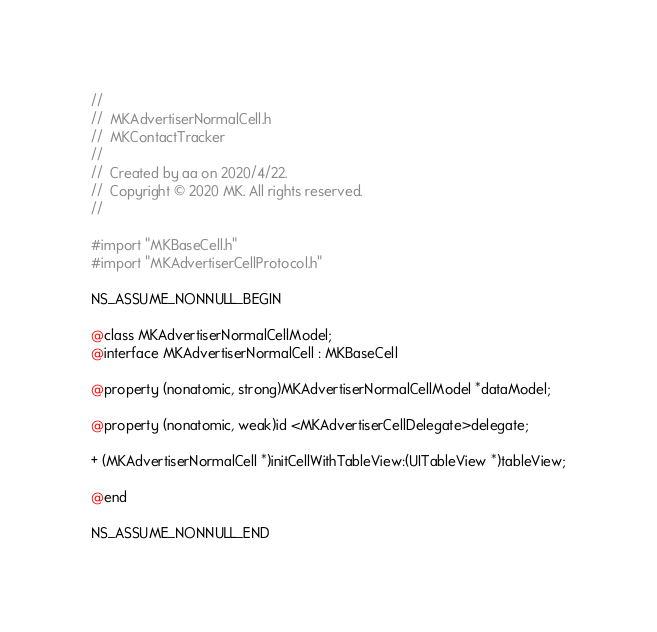Convert code to text. <code><loc_0><loc_0><loc_500><loc_500><_C_>//
//  MKAdvertiserNormalCell.h
//  MKContactTracker
//
//  Created by aa on 2020/4/22.
//  Copyright © 2020 MK. All rights reserved.
//

#import "MKBaseCell.h"
#import "MKAdvertiserCellProtocol.h"

NS_ASSUME_NONNULL_BEGIN

@class MKAdvertiserNormalCellModel;
@interface MKAdvertiserNormalCell : MKBaseCell

@property (nonatomic, strong)MKAdvertiserNormalCellModel *dataModel;

@property (nonatomic, weak)id <MKAdvertiserCellDelegate>delegate;

+ (MKAdvertiserNormalCell *)initCellWithTableView:(UITableView *)tableView;

@end

NS_ASSUME_NONNULL_END
</code> 